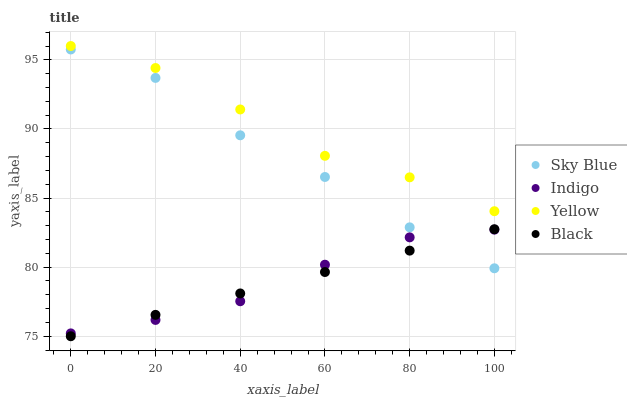Does Black have the minimum area under the curve?
Answer yes or no. Yes. Does Yellow have the maximum area under the curve?
Answer yes or no. Yes. Does Indigo have the minimum area under the curve?
Answer yes or no. No. Does Indigo have the maximum area under the curve?
Answer yes or no. No. Is Black the smoothest?
Answer yes or no. Yes. Is Sky Blue the roughest?
Answer yes or no. Yes. Is Indigo the smoothest?
Answer yes or no. No. Is Indigo the roughest?
Answer yes or no. No. Does Black have the lowest value?
Answer yes or no. Yes. Does Indigo have the lowest value?
Answer yes or no. No. Does Yellow have the highest value?
Answer yes or no. Yes. Does Indigo have the highest value?
Answer yes or no. No. Is Black less than Yellow?
Answer yes or no. Yes. Is Yellow greater than Black?
Answer yes or no. Yes. Does Sky Blue intersect Indigo?
Answer yes or no. Yes. Is Sky Blue less than Indigo?
Answer yes or no. No. Is Sky Blue greater than Indigo?
Answer yes or no. No. Does Black intersect Yellow?
Answer yes or no. No. 